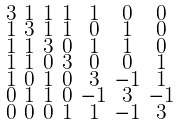<formula> <loc_0><loc_0><loc_500><loc_500>\begin{smallmatrix} 3 & 1 & 1 & 1 & 1 & 0 & 0 \\ 1 & 3 & 1 & 1 & 0 & 1 & 0 \\ 1 & 1 & 3 & 0 & 1 & 1 & 0 \\ 1 & 1 & 0 & 3 & 0 & 0 & 1 \\ 1 & 0 & 1 & 0 & 3 & - 1 & 1 \\ 0 & 1 & 1 & 0 & - 1 & 3 & - 1 \\ 0 & 0 & 0 & 1 & 1 & - 1 & 3 \end{smallmatrix}</formula> 